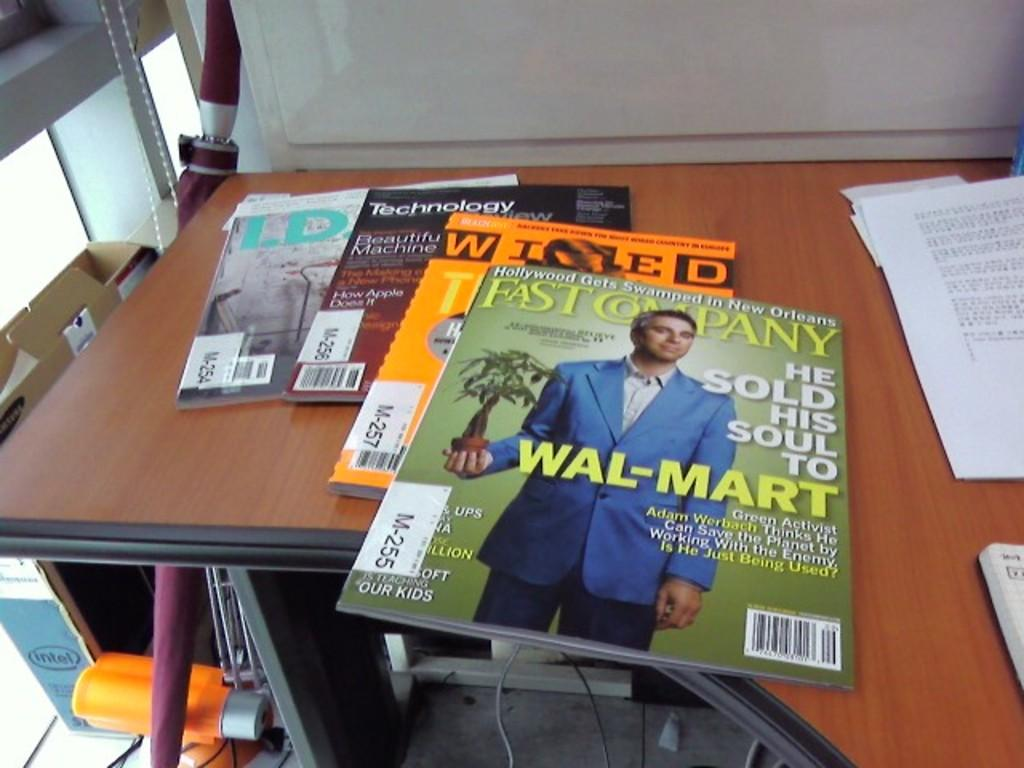What is the main piece of furniture in the image? There is a table in the image. What items are placed on the table? Books are placed on the table. What can be seen on the left side of the image? There is a cardboard box and an object on the left side of the image. What is visible in the background of the image? There is a board in the background of the image. What type of songs can be heard playing in the background of the image? There is no indication of any songs playing in the image. 